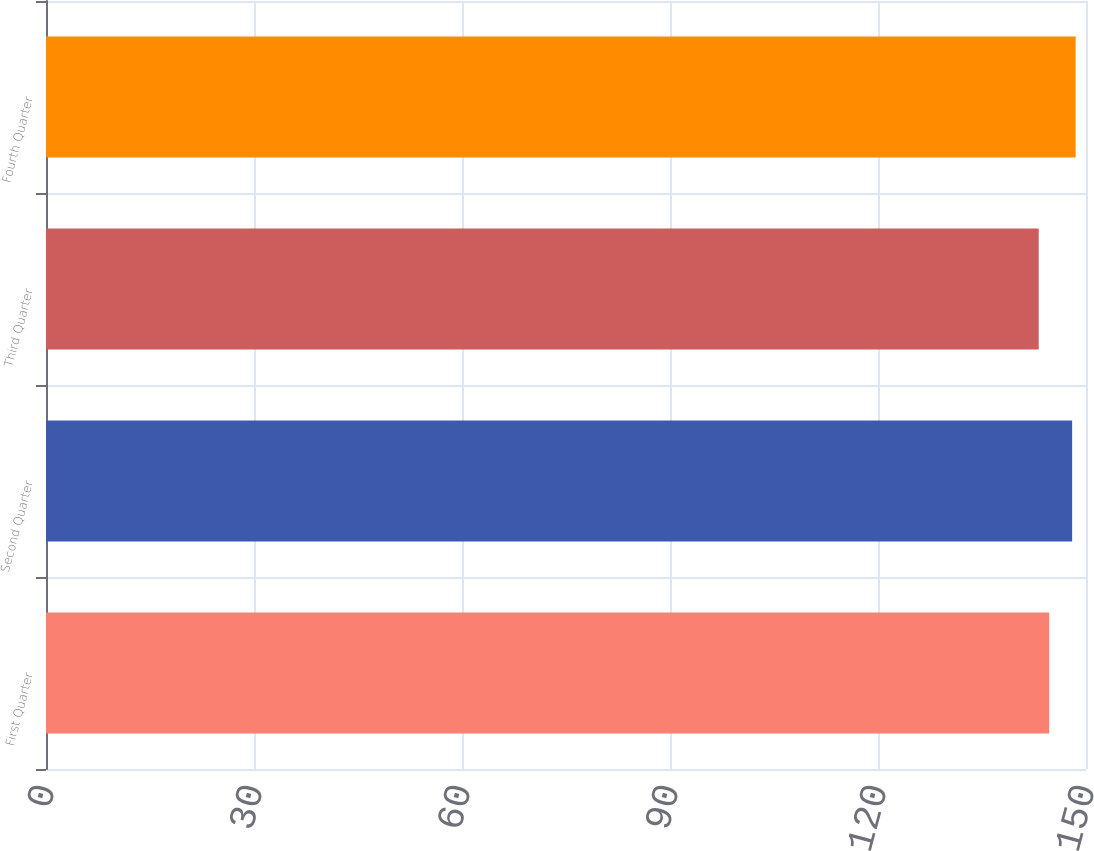<chart> <loc_0><loc_0><loc_500><loc_500><bar_chart><fcel>First Quarter<fcel>Second Quarter<fcel>Third Quarter<fcel>Fourth Quarter<nl><fcel>144.69<fcel>148<fcel>143.18<fcel>148.51<nl></chart> 